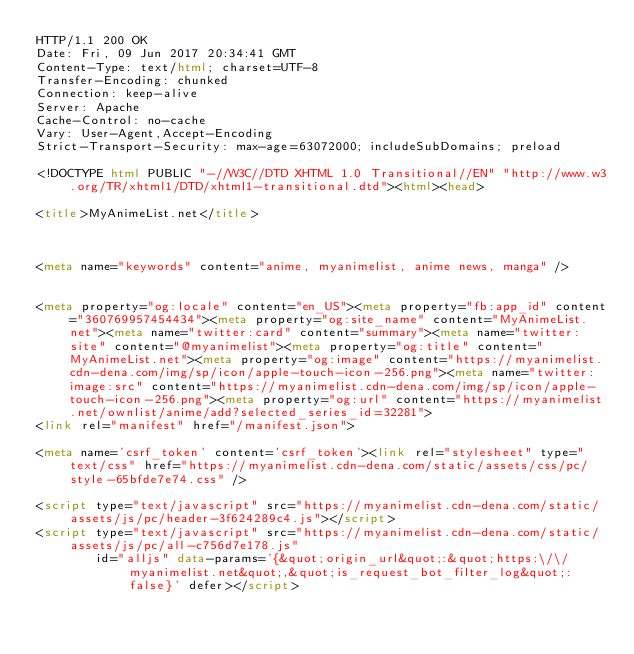Convert code to text. <code><loc_0><loc_0><loc_500><loc_500><_HTML_>HTTP/1.1 200 OK
Date: Fri, 09 Jun 2017 20:34:41 GMT
Content-Type: text/html; charset=UTF-8
Transfer-Encoding: chunked
Connection: keep-alive
Server: Apache
Cache-Control: no-cache
Vary: User-Agent,Accept-Encoding
Strict-Transport-Security: max-age=63072000; includeSubDomains; preload

<!DOCTYPE html PUBLIC "-//W3C//DTD XHTML 1.0 Transitional//EN" "http://www.w3.org/TR/xhtml1/DTD/xhtml1-transitional.dtd"><html><head>

<title>MyAnimeList.net</title>



<meta name="keywords" content="anime, myanimelist, anime news, manga" />


<meta property="og:locale" content="en_US"><meta property="fb:app_id" content="360769957454434"><meta property="og:site_name" content="MyAnimeList.net"><meta name="twitter:card" content="summary"><meta name="twitter:site" content="@myanimelist"><meta property="og:title" content="MyAnimeList.net"><meta property="og:image" content="https://myanimelist.cdn-dena.com/img/sp/icon/apple-touch-icon-256.png"><meta name="twitter:image:src" content="https://myanimelist.cdn-dena.com/img/sp/icon/apple-touch-icon-256.png"><meta property="og:url" content="https://myanimelist.net/ownlist/anime/add?selected_series_id=32281">
<link rel="manifest" href="/manifest.json">

<meta name='csrf_token' content='csrf_token'><link rel="stylesheet" type="text/css" href="https://myanimelist.cdn-dena.com/static/assets/css/pc/style-65bfde7e74.css" />

<script type="text/javascript" src="https://myanimelist.cdn-dena.com/static/assets/js/pc/header-3f624289c4.js"></script>
<script type="text/javascript" src="https://myanimelist.cdn-dena.com/static/assets/js/pc/all-c756d7e178.js"
        id="alljs" data-params='{&quot;origin_url&quot;:&quot;https:\/\/myanimelist.net&quot;,&quot;is_request_bot_filter_log&quot;:false}' defer></script>


</code> 